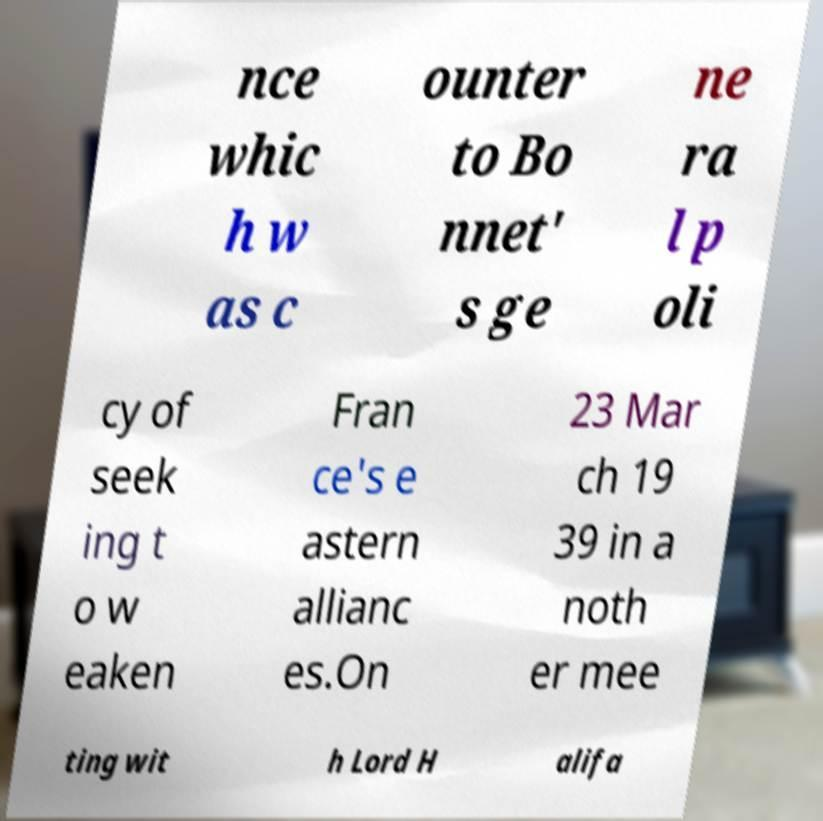Please read and relay the text visible in this image. What does it say? nce whic h w as c ounter to Bo nnet' s ge ne ra l p oli cy of seek ing t o w eaken Fran ce's e astern allianc es.On 23 Mar ch 19 39 in a noth er mee ting wit h Lord H alifa 